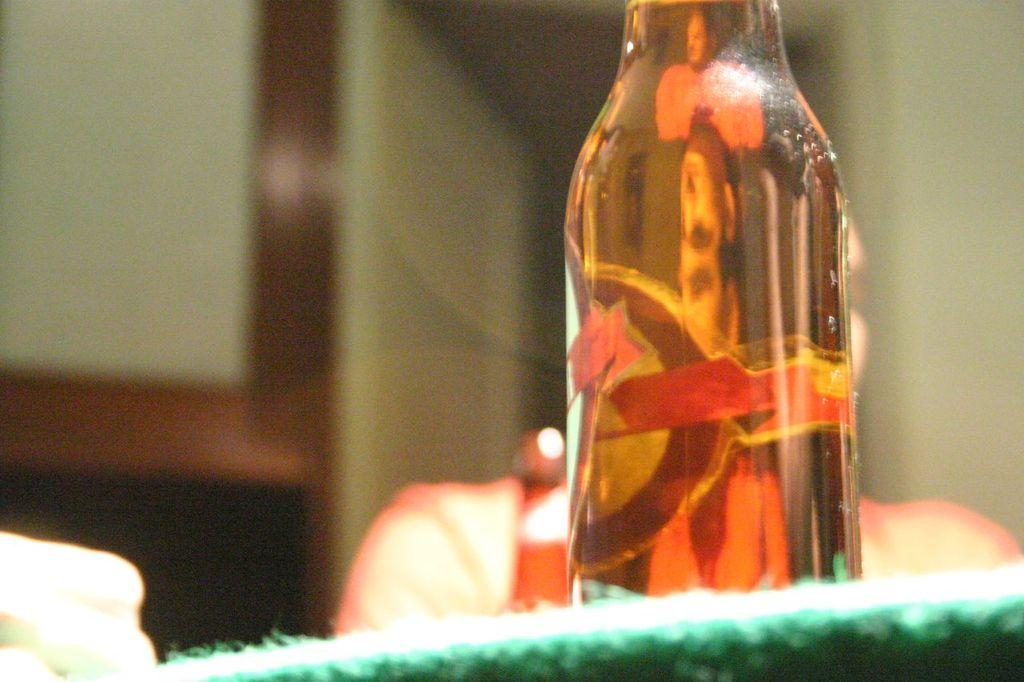What object can be seen in the image? There is a bottle in the image. Where is the bottle located? The bottle is on a table. What type of rat is sitting on the expert's shoulder in the image? There is no rat or expert present in the image; it only features a bottle on a table. 